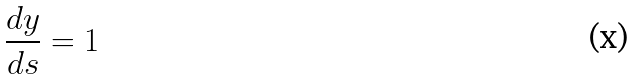<formula> <loc_0><loc_0><loc_500><loc_500>\frac { d y } { d s } = 1</formula> 